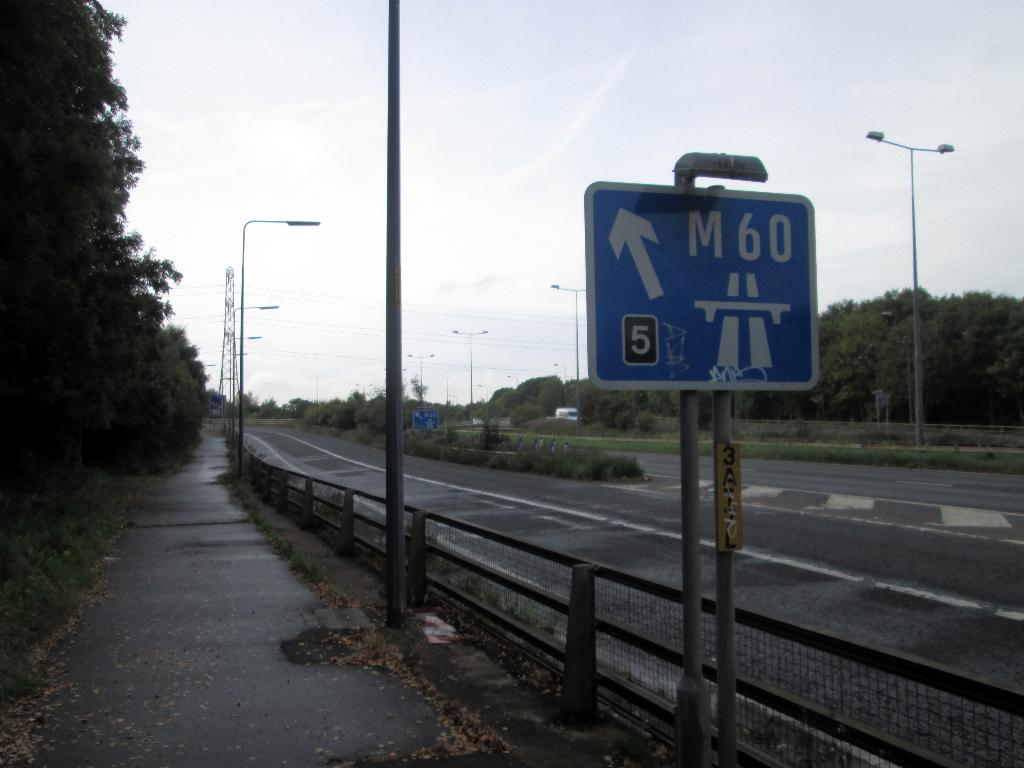<image>
Describe the image concisely. A blue street sign with M 60 on it. 